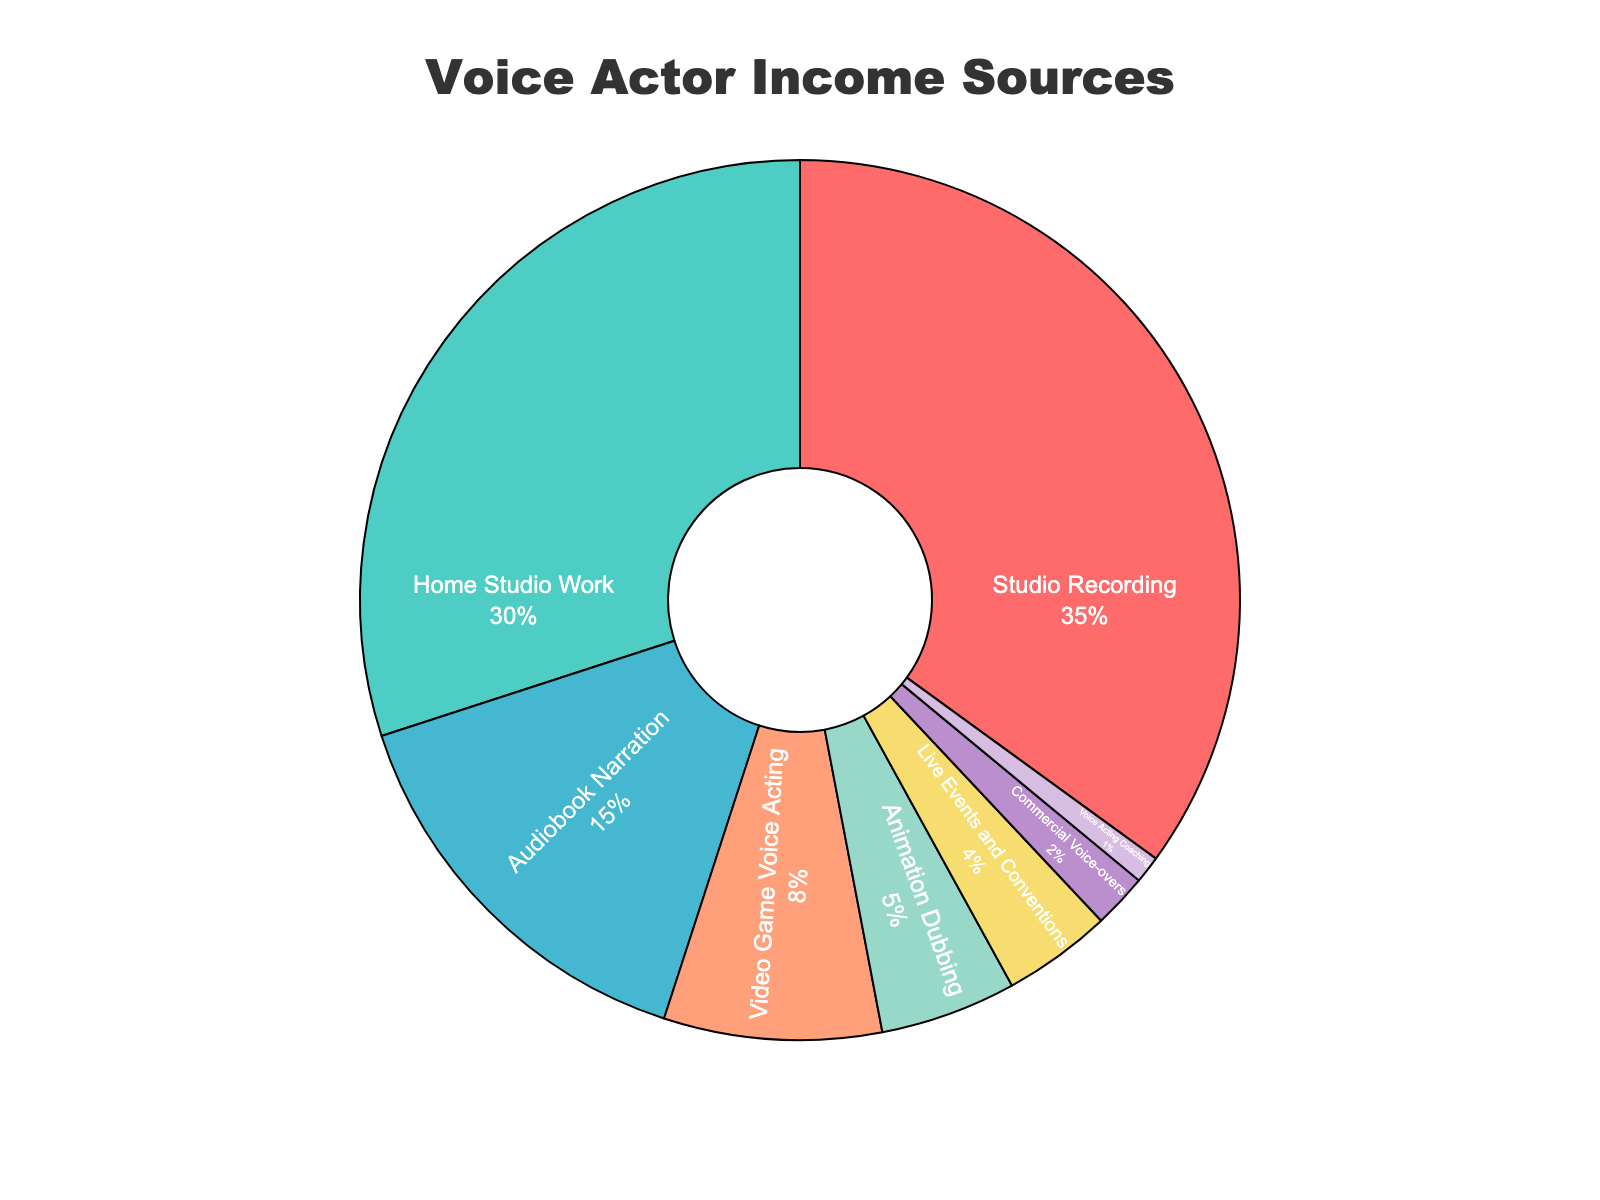What percentage of income comes from studio recording and home studio work combined? Add the percentages for studio recording and home studio work: 35% + 30% = 65%
Answer: 65% Which income source has the smallest percentage, and what is it? Look at the pie chart and identify the smallest segment, which is voice acting coaching at 1%
Answer: Voice Acting Coaching, 1% By how much does the percentage of audiobook narration exceed the percentage of animation dubbing? Subtract the percentage of animation dubbing from audiobook narration: 15% - 5% = 10%
Answer: 10% Are live events and conventions more or less significant than video game voice acting, and by what margin? Compare the percentages of live events and conventions (4%) to video game voice acting (8%): 8% - 4% = 4%. Video game voice acting is more significant by 4%
Answer: More significant, 4% How much more do live events and conventions contribute compared to commercial voice-overs? Subtract the percentage of commercial voice-overs from live events and conventions: 4% - 2% = 2%
Answer: 2% What's the combined percentage for all sources contributing less than 10% each? Add the percentages for sources contributing less than 10%: Audiobook Narration (15%) + Video Game Voice Acting (8%) + Animation Dubbing (5%) + Live Events and Conventions (4%) + Commercial Voice-overs (2%) + Voice Acting Coaching (1%) = 35%
Answer: 35% What is the average percentage of income sources excluding studio recording and home studio work? Add the percentages of Audiobook Narration (15%), Video Game Voice Acting (8%), Animation Dubbing (5%), Live Events and Conventions (4%), Commercial Voice-overs (2%), and Voice Acting Coaching (1%). The total is 35%. Divide by the number of sources: 35% / 6 ≈ 5.83%
Answer: 5.83% Which sources account for more than half of the voice actor income, and what are their percentages? Identify sources with percentages greater than 50% combined. Studio Recording (35%) and Home Studio Work (30%) together account for 65%, which is more than half
Answer: Studio Recording and Home Studio Work, 65% 